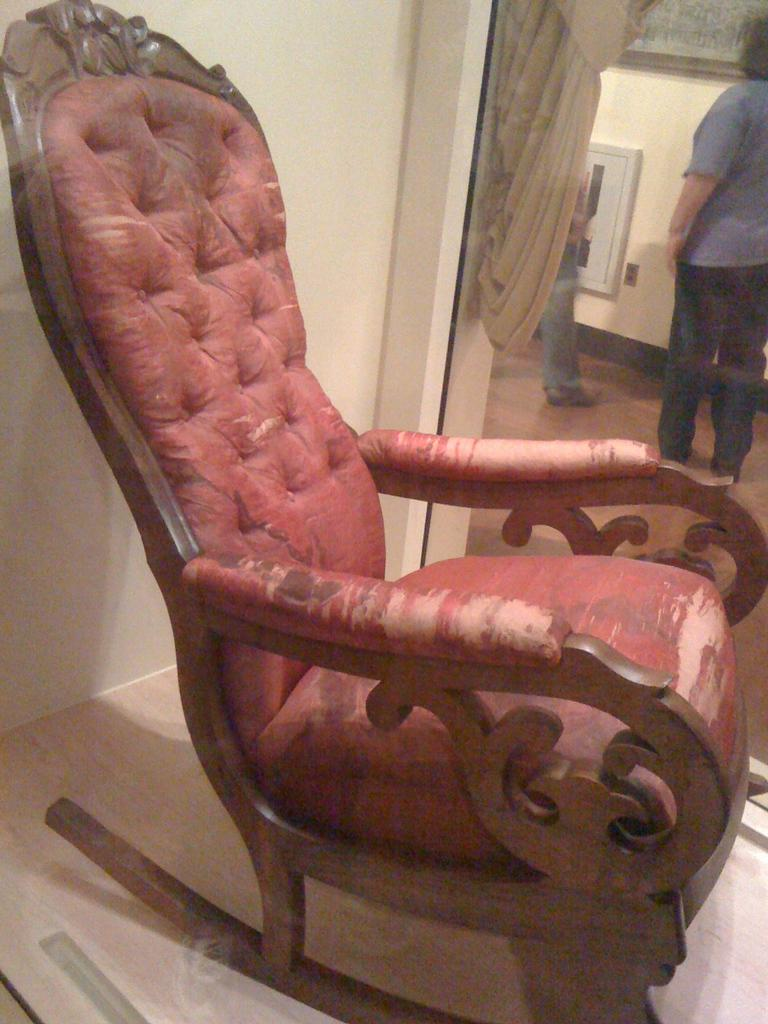What type of furniture is present in the image? There is a chair in the image. Can you describe the color of the chair? The chair is brown and red in color. What else can be seen in the image besides the chair? There is a curtain, two people standing, and a wall visible in the image. Where are the people standing in the image? The people are standing on the floor. Can you tell me how many monkeys are sitting on the tramp in the image? There are no monkeys or tramps present in the image. 